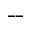<formula> <loc_0><loc_0><loc_500><loc_500>- -</formula> 